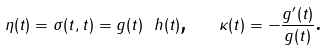<formula> <loc_0><loc_0><loc_500><loc_500>\eta ( t ) = \sigma ( t , t ) = g ( t ) \ h ( t ) \text {,} \quad \kappa ( t ) = - \frac { g ^ { \prime } ( t ) } { g ( t ) } \text {.}</formula> 